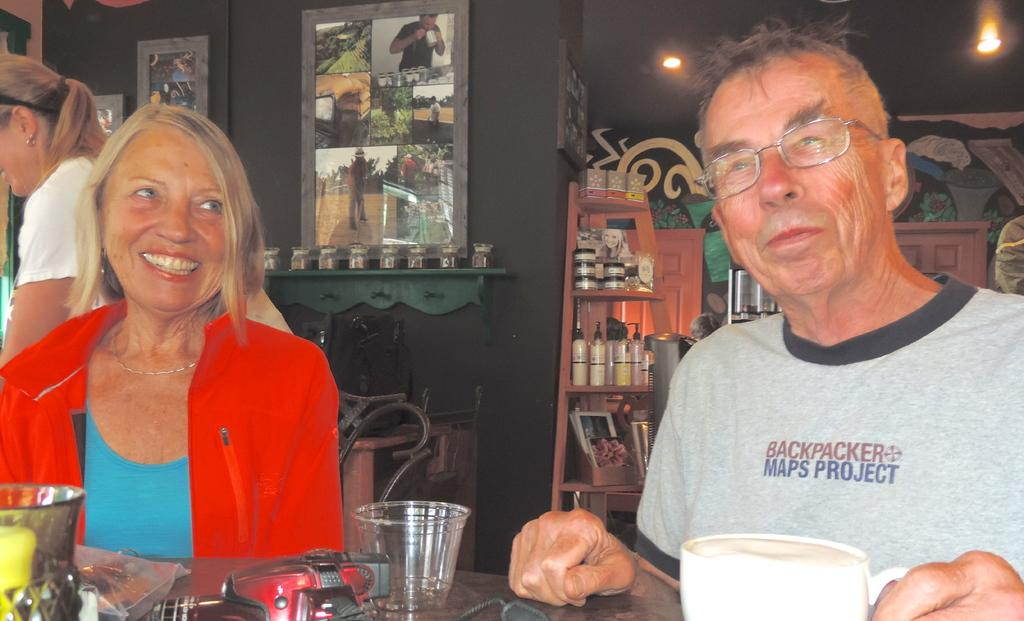Who is present in the image? There is an old couple in the image. What are the old couple doing in the image? The old couple is sitting at a table. Where is the table located? The table is in a coffee shop. Can you describe the scene in the background of the image? There is a woman in the background of the image. What type of zinc is visible on the table in the image? There is no zinc present on the table in the image. How much rice is being served to the old couple in the image? There is no rice present in the image. 